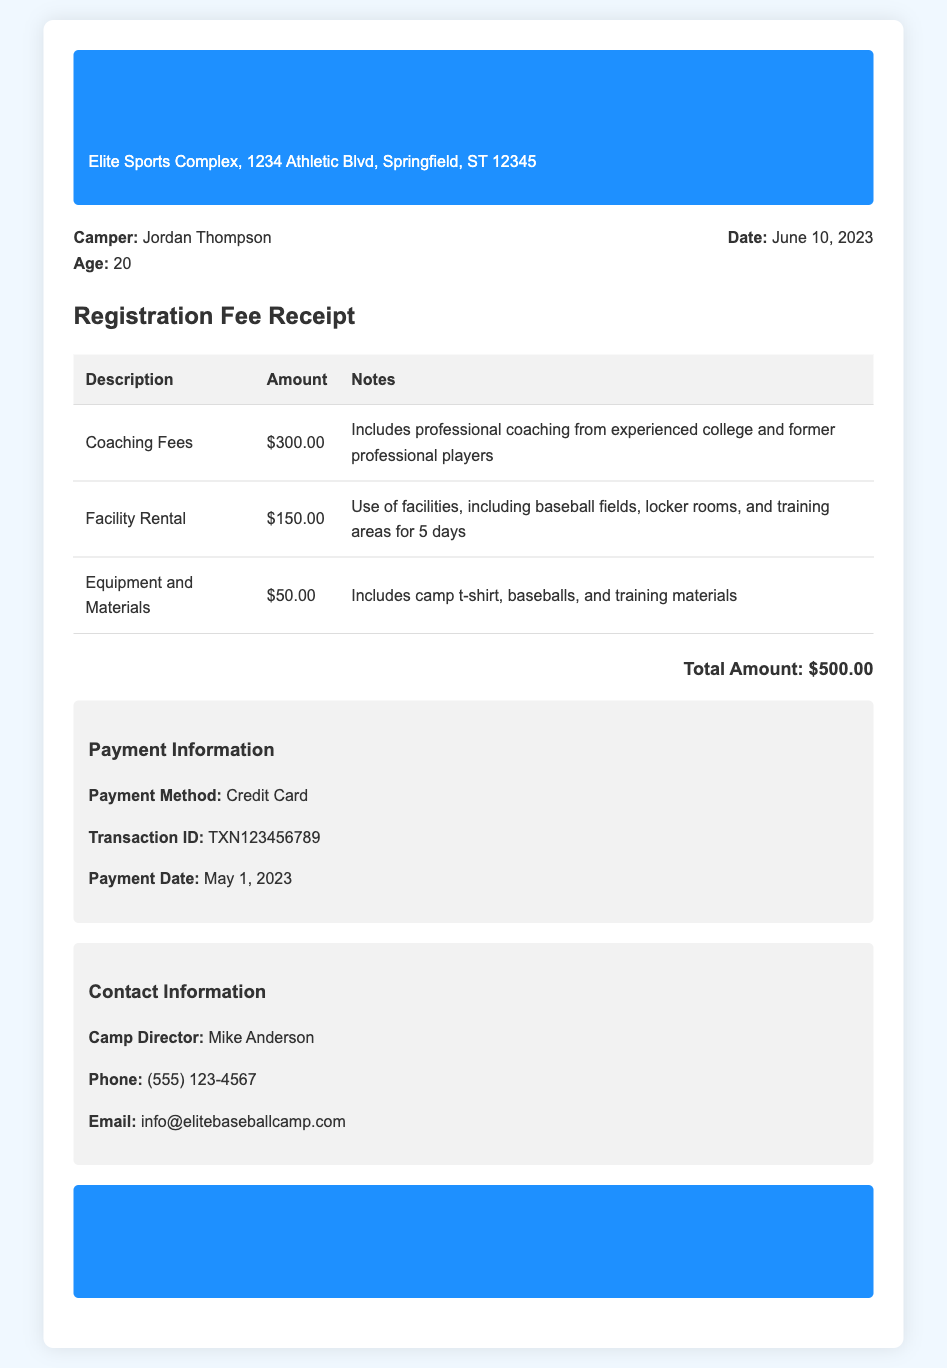What is the camper's name? The camper's name is displayed in the document under camper information.
Answer: Jordan Thompson What is the total amount of the registration fee? The total amount is provided at the end of the receipt after adding all expenses.
Answer: $500.00 Who is the camp director? The document lists the camp director's name in the contact information section.
Answer: Mike Anderson How much are the coaching fees? The amount for coaching fees is mentioned in the breakdown table.
Answer: $300.00 What payment method was used? The payment method is specified in the payment information section of the document.
Answer: Credit Card What facilities are included in the rental fee? The notes for the facility rental state what facilities are being used during the camp.
Answer: baseball fields, locker rooms, and training areas What date was the payment made? The date of payment is included in the payment information section.
Answer: May 1, 2023 How many days does the facility rental cover? The notes in the facility rental section mention the duration of the rental.
Answer: 5 days What is included in the equipment and materials? The notes for equipment and materials detail the items covered under this fee.
Answer: camp t-shirt, baseballs, and training materials 